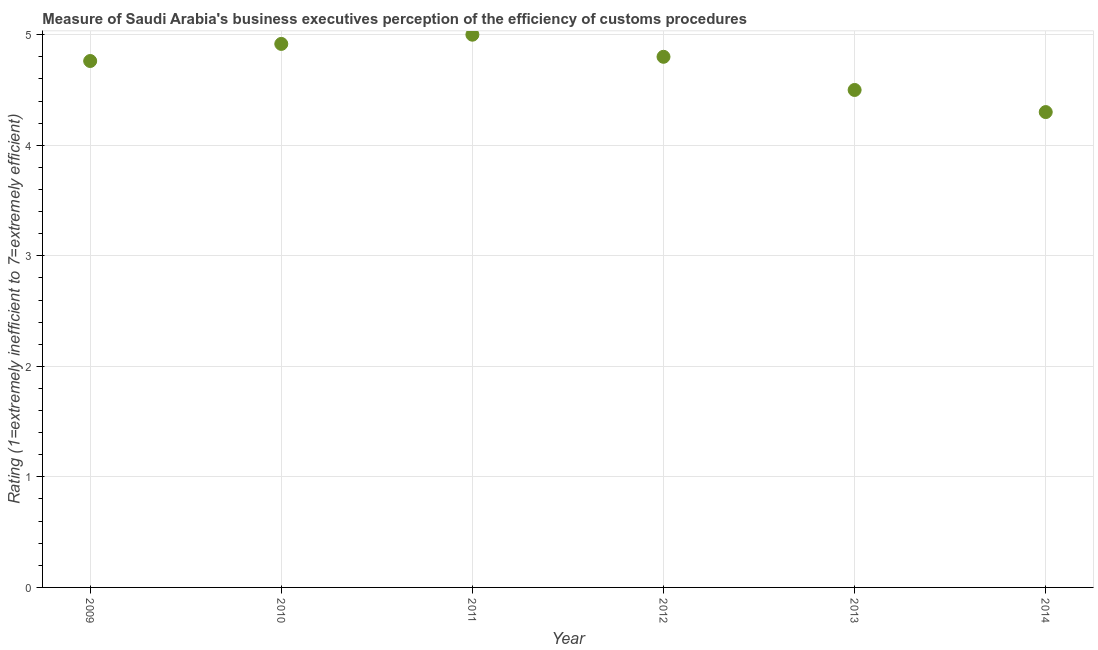What is the rating measuring burden of customs procedure in 2009?
Make the answer very short. 4.76. In which year was the rating measuring burden of customs procedure maximum?
Your response must be concise. 2011. What is the sum of the rating measuring burden of customs procedure?
Your answer should be very brief. 28.28. What is the difference between the rating measuring burden of customs procedure in 2011 and 2012?
Your answer should be very brief. 0.2. What is the average rating measuring burden of customs procedure per year?
Keep it short and to the point. 4.71. What is the median rating measuring burden of customs procedure?
Give a very brief answer. 4.78. What is the ratio of the rating measuring burden of customs procedure in 2010 to that in 2012?
Keep it short and to the point. 1.02. Is the difference between the rating measuring burden of customs procedure in 2010 and 2014 greater than the difference between any two years?
Your answer should be compact. No. What is the difference between the highest and the second highest rating measuring burden of customs procedure?
Provide a succinct answer. 0.08. Is the sum of the rating measuring burden of customs procedure in 2009 and 2010 greater than the maximum rating measuring burden of customs procedure across all years?
Offer a terse response. Yes. What is the difference between the highest and the lowest rating measuring burden of customs procedure?
Provide a succinct answer. 0.7. In how many years, is the rating measuring burden of customs procedure greater than the average rating measuring burden of customs procedure taken over all years?
Your response must be concise. 4. Does the rating measuring burden of customs procedure monotonically increase over the years?
Keep it short and to the point. No. How many dotlines are there?
Keep it short and to the point. 1. How many years are there in the graph?
Provide a short and direct response. 6. What is the difference between two consecutive major ticks on the Y-axis?
Make the answer very short. 1. Are the values on the major ticks of Y-axis written in scientific E-notation?
Make the answer very short. No. Does the graph contain grids?
Provide a short and direct response. Yes. What is the title of the graph?
Give a very brief answer. Measure of Saudi Arabia's business executives perception of the efficiency of customs procedures. What is the label or title of the X-axis?
Provide a short and direct response. Year. What is the label or title of the Y-axis?
Provide a short and direct response. Rating (1=extremely inefficient to 7=extremely efficient). What is the Rating (1=extremely inefficient to 7=extremely efficient) in 2009?
Provide a short and direct response. 4.76. What is the Rating (1=extremely inefficient to 7=extremely efficient) in 2010?
Your response must be concise. 4.92. What is the Rating (1=extremely inefficient to 7=extremely efficient) in 2011?
Offer a very short reply. 5. What is the Rating (1=extremely inefficient to 7=extremely efficient) in 2012?
Keep it short and to the point. 4.8. What is the Rating (1=extremely inefficient to 7=extremely efficient) in 2014?
Offer a very short reply. 4.3. What is the difference between the Rating (1=extremely inefficient to 7=extremely efficient) in 2009 and 2010?
Offer a very short reply. -0.15. What is the difference between the Rating (1=extremely inefficient to 7=extremely efficient) in 2009 and 2011?
Offer a very short reply. -0.24. What is the difference between the Rating (1=extremely inefficient to 7=extremely efficient) in 2009 and 2012?
Make the answer very short. -0.04. What is the difference between the Rating (1=extremely inefficient to 7=extremely efficient) in 2009 and 2013?
Offer a terse response. 0.26. What is the difference between the Rating (1=extremely inefficient to 7=extremely efficient) in 2009 and 2014?
Offer a very short reply. 0.46. What is the difference between the Rating (1=extremely inefficient to 7=extremely efficient) in 2010 and 2011?
Give a very brief answer. -0.08. What is the difference between the Rating (1=extremely inefficient to 7=extremely efficient) in 2010 and 2012?
Your answer should be very brief. 0.12. What is the difference between the Rating (1=extremely inefficient to 7=extremely efficient) in 2010 and 2013?
Make the answer very short. 0.42. What is the difference between the Rating (1=extremely inefficient to 7=extremely efficient) in 2010 and 2014?
Your answer should be very brief. 0.62. What is the difference between the Rating (1=extremely inefficient to 7=extremely efficient) in 2011 and 2013?
Your answer should be compact. 0.5. What is the difference between the Rating (1=extremely inefficient to 7=extremely efficient) in 2011 and 2014?
Your answer should be compact. 0.7. What is the difference between the Rating (1=extremely inefficient to 7=extremely efficient) in 2012 and 2013?
Provide a succinct answer. 0.3. What is the difference between the Rating (1=extremely inefficient to 7=extremely efficient) in 2013 and 2014?
Ensure brevity in your answer.  0.2. What is the ratio of the Rating (1=extremely inefficient to 7=extremely efficient) in 2009 to that in 2011?
Your answer should be compact. 0.95. What is the ratio of the Rating (1=extremely inefficient to 7=extremely efficient) in 2009 to that in 2012?
Offer a very short reply. 0.99. What is the ratio of the Rating (1=extremely inefficient to 7=extremely efficient) in 2009 to that in 2013?
Provide a short and direct response. 1.06. What is the ratio of the Rating (1=extremely inefficient to 7=extremely efficient) in 2009 to that in 2014?
Your response must be concise. 1.11. What is the ratio of the Rating (1=extremely inefficient to 7=extremely efficient) in 2010 to that in 2012?
Make the answer very short. 1.02. What is the ratio of the Rating (1=extremely inefficient to 7=extremely efficient) in 2010 to that in 2013?
Offer a very short reply. 1.09. What is the ratio of the Rating (1=extremely inefficient to 7=extremely efficient) in 2010 to that in 2014?
Keep it short and to the point. 1.14. What is the ratio of the Rating (1=extremely inefficient to 7=extremely efficient) in 2011 to that in 2012?
Offer a terse response. 1.04. What is the ratio of the Rating (1=extremely inefficient to 7=extremely efficient) in 2011 to that in 2013?
Your answer should be compact. 1.11. What is the ratio of the Rating (1=extremely inefficient to 7=extremely efficient) in 2011 to that in 2014?
Your answer should be very brief. 1.16. What is the ratio of the Rating (1=extremely inefficient to 7=extremely efficient) in 2012 to that in 2013?
Offer a terse response. 1.07. What is the ratio of the Rating (1=extremely inefficient to 7=extremely efficient) in 2012 to that in 2014?
Offer a terse response. 1.12. What is the ratio of the Rating (1=extremely inefficient to 7=extremely efficient) in 2013 to that in 2014?
Provide a succinct answer. 1.05. 